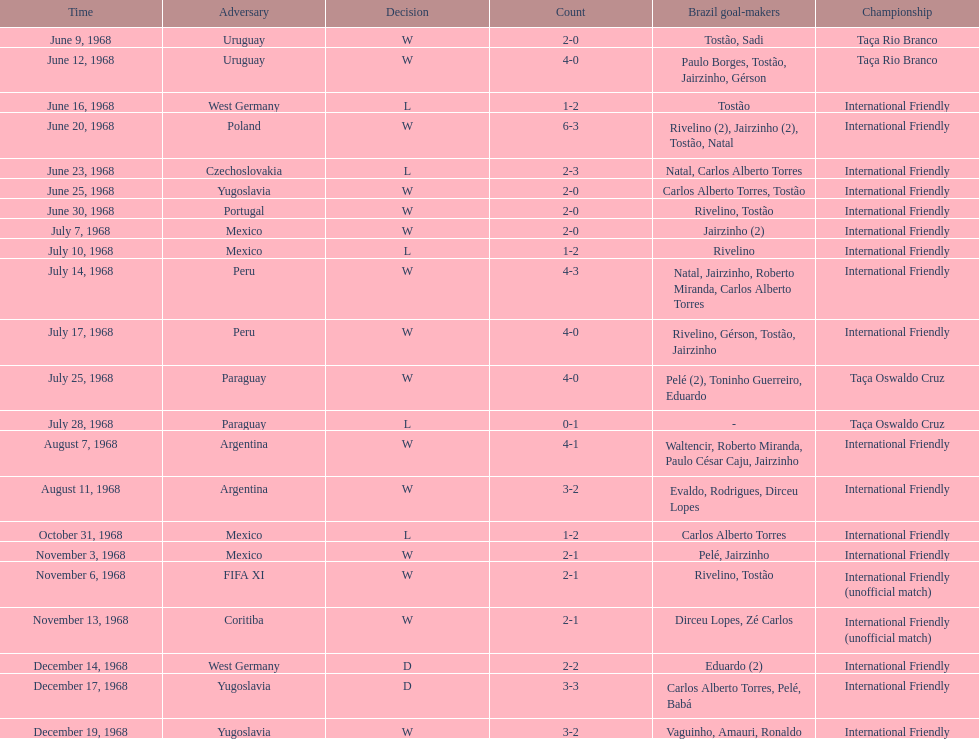What year has the highest scoring game? 1968. 